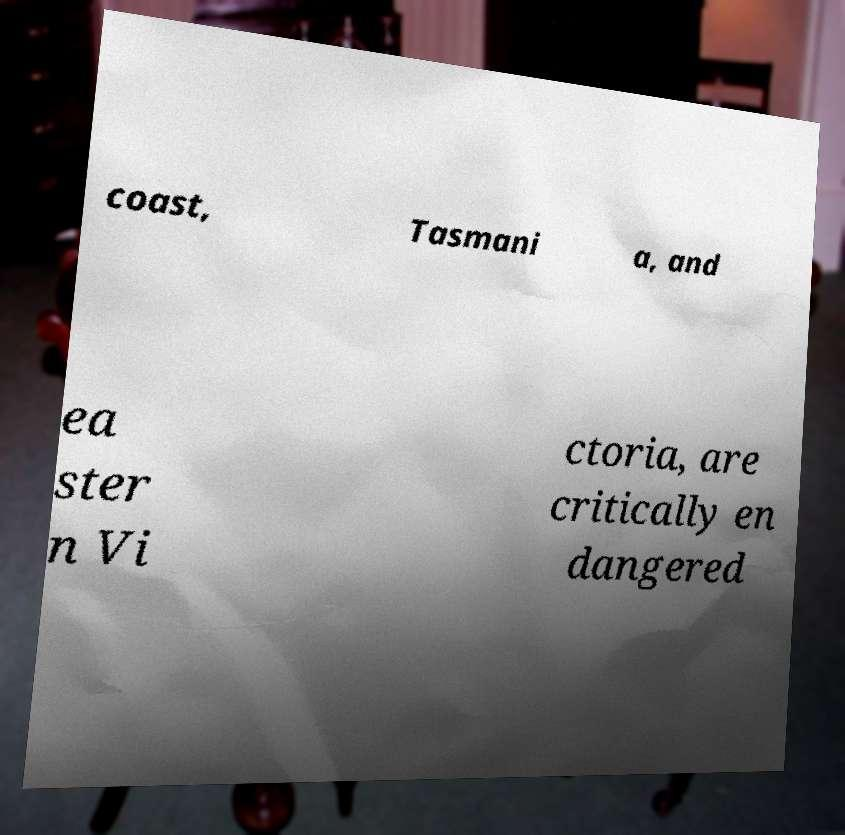Please read and relay the text visible in this image. What does it say? coast, Tasmani a, and ea ster n Vi ctoria, are critically en dangered 